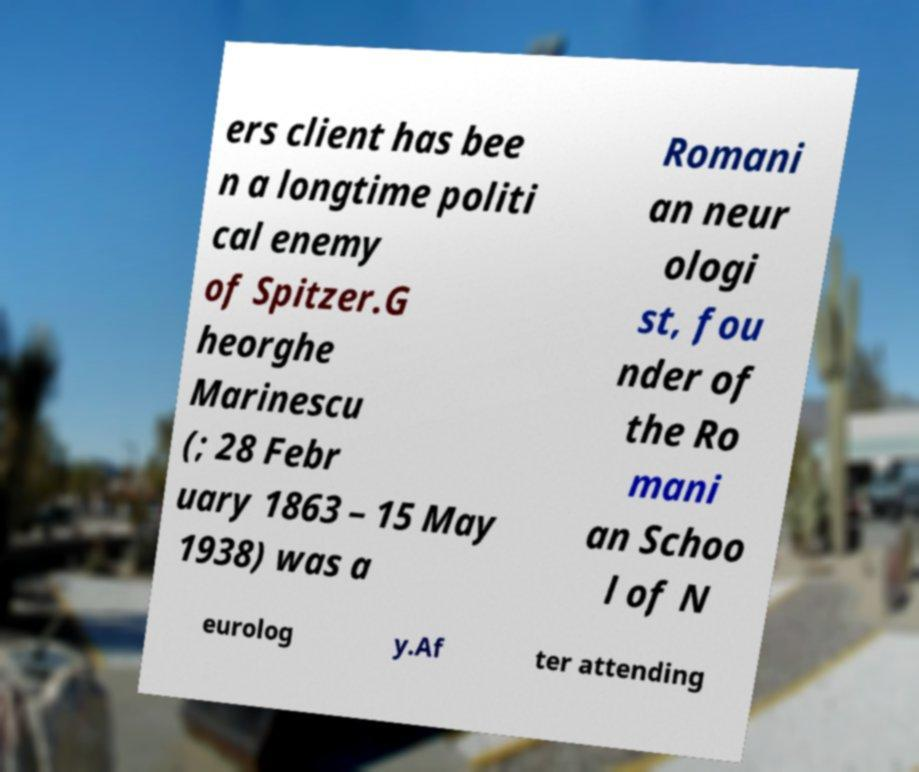There's text embedded in this image that I need extracted. Can you transcribe it verbatim? ers client has bee n a longtime politi cal enemy of Spitzer.G heorghe Marinescu (; 28 Febr uary 1863 – 15 May 1938) was a Romani an neur ologi st, fou nder of the Ro mani an Schoo l of N eurolog y.Af ter attending 